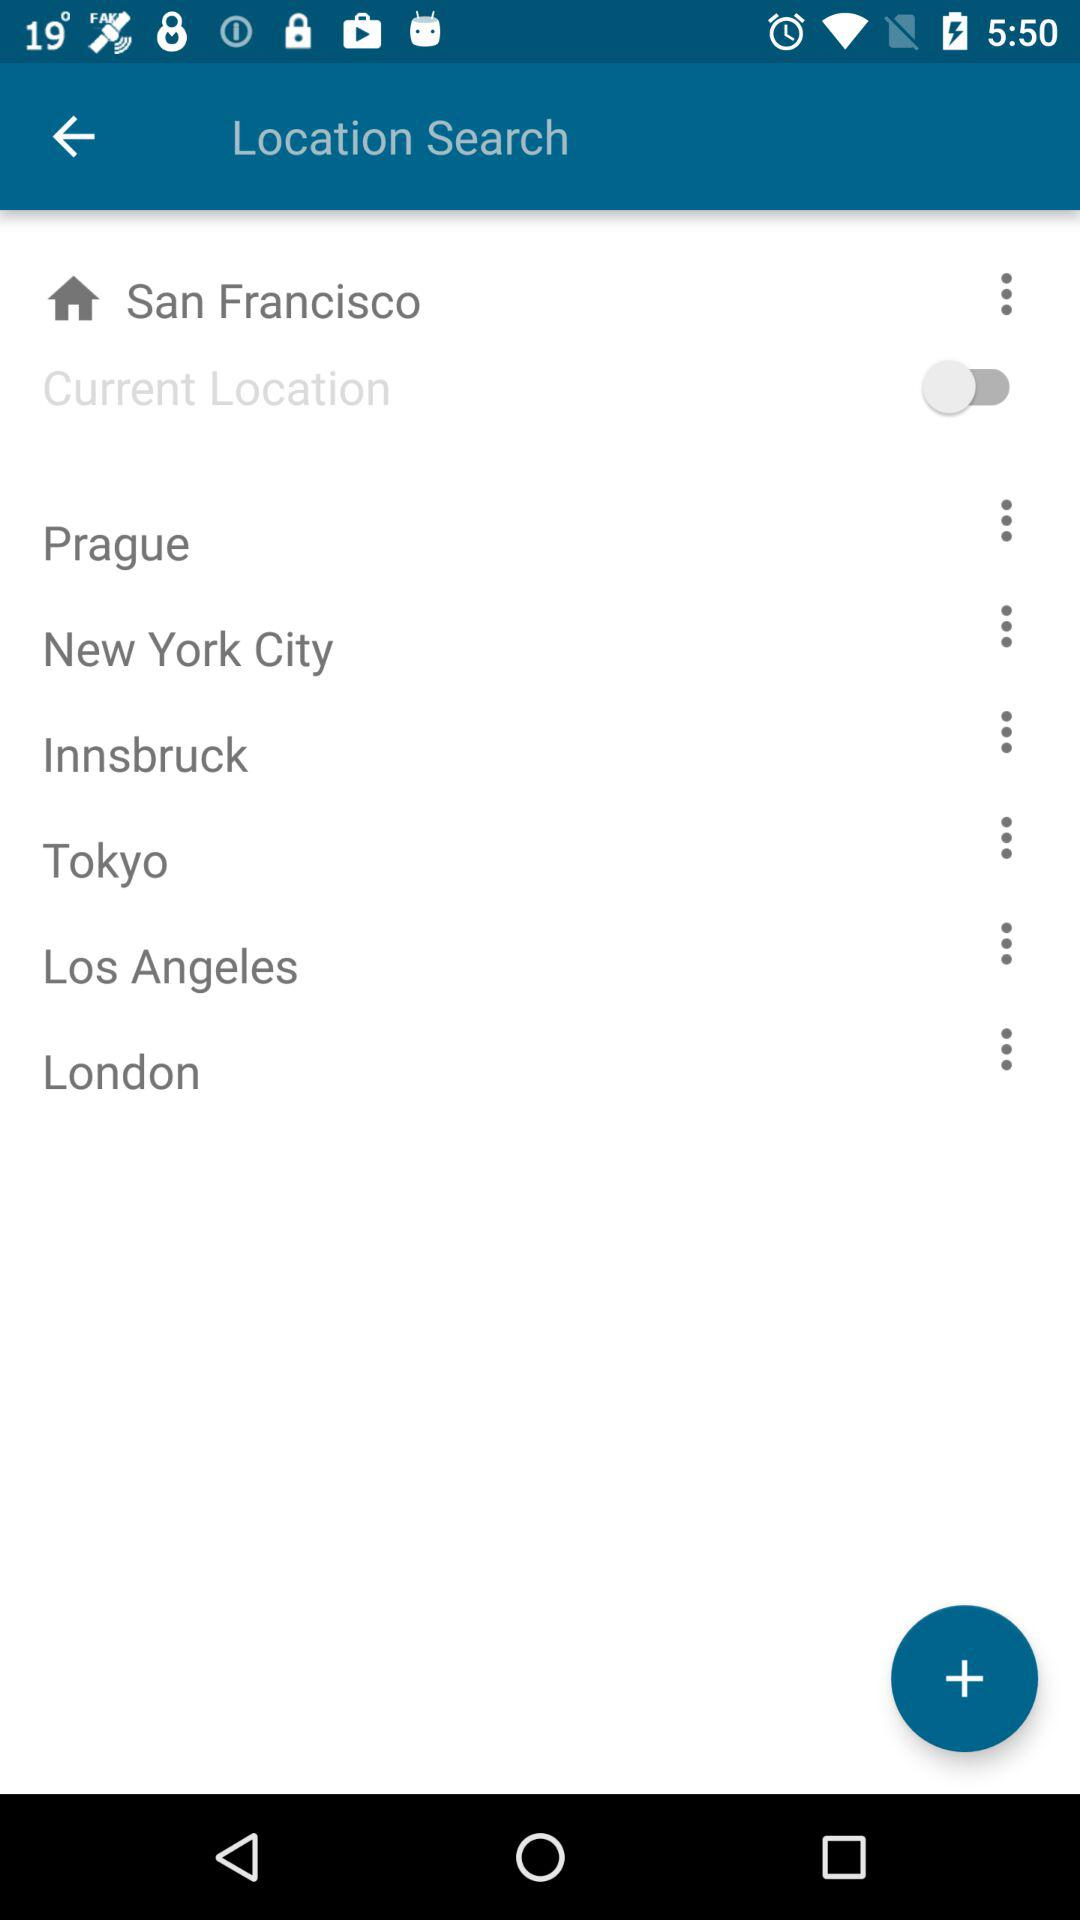What is the current location? The current location is San Francisco. 